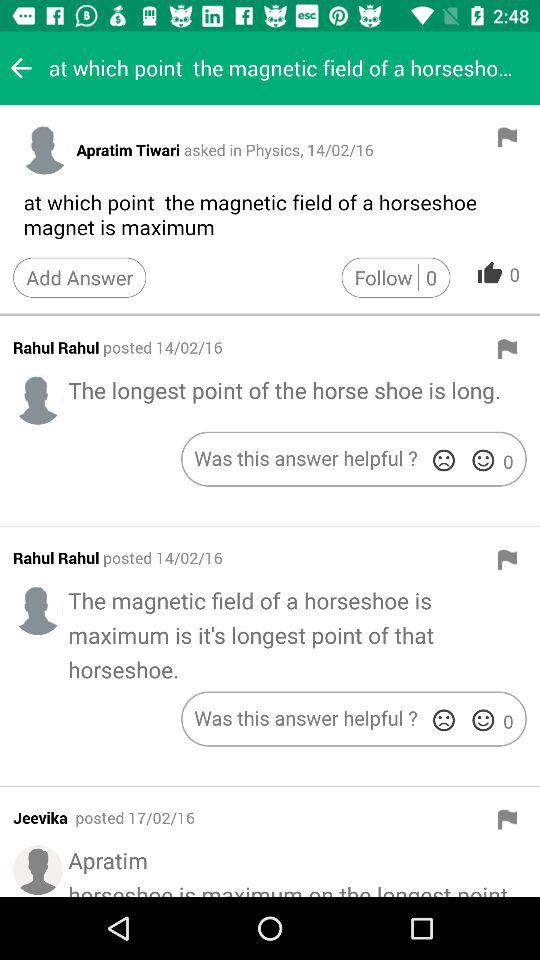When was the Jeevika posted? The Jeevika was posted on February 17, 2016. 